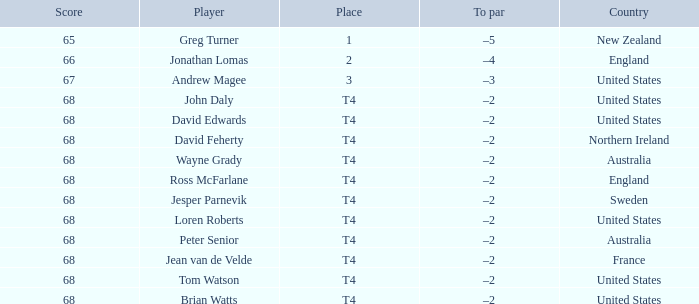Who has a To par of –2, and a Country of united states? John Daly, David Edwards, Loren Roberts, Tom Watson, Brian Watts. 